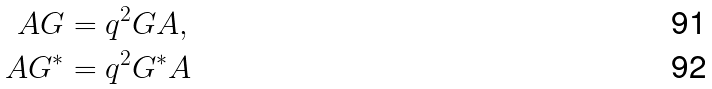Convert formula to latex. <formula><loc_0><loc_0><loc_500><loc_500>A G & = q ^ { 2 } G A , \\ A G ^ { * } & = q ^ { 2 } G ^ { * } A</formula> 